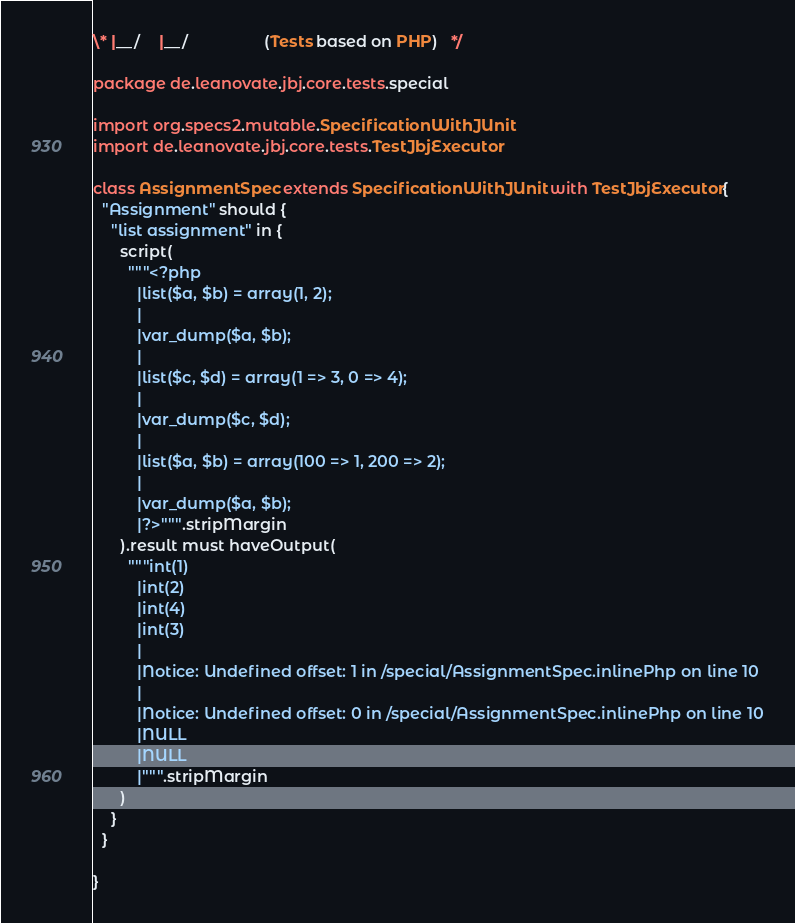Convert code to text. <code><loc_0><loc_0><loc_500><loc_500><_Scala_>\* |__/    |__/                 (Tests based on PHP)   */

package de.leanovate.jbj.core.tests.special

import org.specs2.mutable.SpecificationWithJUnit
import de.leanovate.jbj.core.tests.TestJbjExecutor

class AssignmentSpec extends SpecificationWithJUnit with TestJbjExecutor{
  "Assignment" should {
    "list assignment" in {
      script(
        """<?php
          |list($a, $b) = array(1, 2);
          |
          |var_dump($a, $b);
          |
          |list($c, $d) = array(1 => 3, 0 => 4);
          |
          |var_dump($c, $d);
          |
          |list($a, $b) = array(100 => 1, 200 => 2);
          |
          |var_dump($a, $b);
          |?>""".stripMargin
      ).result must haveOutput(
        """int(1)
          |int(2)
          |int(4)
          |int(3)
          |
          |Notice: Undefined offset: 1 in /special/AssignmentSpec.inlinePhp on line 10
          |
          |Notice: Undefined offset: 0 in /special/AssignmentSpec.inlinePhp on line 10
          |NULL
          |NULL
          |""".stripMargin
      )
    }
  }

}
</code> 